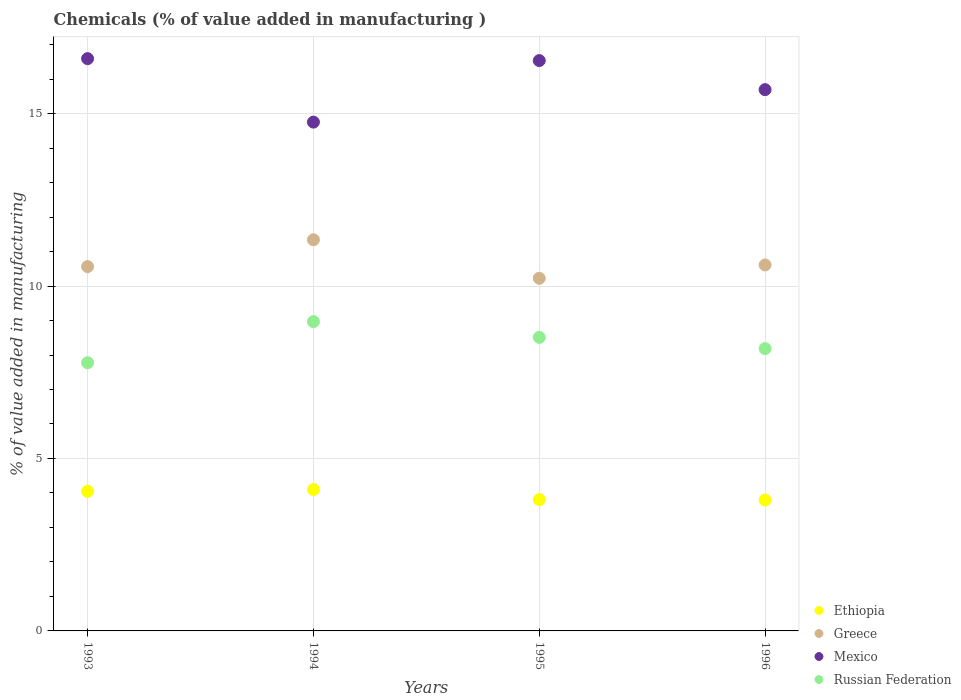Is the number of dotlines equal to the number of legend labels?
Provide a succinct answer. Yes. What is the value added in manufacturing chemicals in Ethiopia in 1994?
Offer a terse response. 4.1. Across all years, what is the maximum value added in manufacturing chemicals in Russian Federation?
Offer a very short reply. 8.97. Across all years, what is the minimum value added in manufacturing chemicals in Greece?
Give a very brief answer. 10.22. In which year was the value added in manufacturing chemicals in Mexico maximum?
Offer a very short reply. 1993. What is the total value added in manufacturing chemicals in Greece in the graph?
Offer a very short reply. 42.74. What is the difference between the value added in manufacturing chemicals in Ethiopia in 1994 and that in 1996?
Offer a terse response. 0.3. What is the difference between the value added in manufacturing chemicals in Mexico in 1995 and the value added in manufacturing chemicals in Greece in 1996?
Keep it short and to the point. 5.93. What is the average value added in manufacturing chemicals in Russian Federation per year?
Your response must be concise. 8.36. In the year 1996, what is the difference between the value added in manufacturing chemicals in Russian Federation and value added in manufacturing chemicals in Greece?
Offer a terse response. -2.43. What is the ratio of the value added in manufacturing chemicals in Ethiopia in 1995 to that in 1996?
Offer a very short reply. 1. Is the value added in manufacturing chemicals in Mexico in 1994 less than that in 1995?
Your response must be concise. Yes. Is the difference between the value added in manufacturing chemicals in Russian Federation in 1994 and 1995 greater than the difference between the value added in manufacturing chemicals in Greece in 1994 and 1995?
Give a very brief answer. No. What is the difference between the highest and the second highest value added in manufacturing chemicals in Russian Federation?
Keep it short and to the point. 0.46. What is the difference between the highest and the lowest value added in manufacturing chemicals in Greece?
Offer a terse response. 1.12. Is it the case that in every year, the sum of the value added in manufacturing chemicals in Ethiopia and value added in manufacturing chemicals in Russian Federation  is greater than the sum of value added in manufacturing chemicals in Greece and value added in manufacturing chemicals in Mexico?
Your answer should be compact. No. Does the value added in manufacturing chemicals in Mexico monotonically increase over the years?
Your answer should be compact. No. How many years are there in the graph?
Offer a terse response. 4. What is the difference between two consecutive major ticks on the Y-axis?
Offer a terse response. 5. Are the values on the major ticks of Y-axis written in scientific E-notation?
Ensure brevity in your answer.  No. Does the graph contain any zero values?
Provide a short and direct response. No. How many legend labels are there?
Offer a terse response. 4. How are the legend labels stacked?
Your response must be concise. Vertical. What is the title of the graph?
Your answer should be very brief. Chemicals (% of value added in manufacturing ). What is the label or title of the X-axis?
Provide a succinct answer. Years. What is the label or title of the Y-axis?
Offer a very short reply. % of value added in manufacturing. What is the % of value added in manufacturing in Ethiopia in 1993?
Ensure brevity in your answer.  4.05. What is the % of value added in manufacturing of Greece in 1993?
Keep it short and to the point. 10.56. What is the % of value added in manufacturing in Mexico in 1993?
Make the answer very short. 16.59. What is the % of value added in manufacturing in Russian Federation in 1993?
Offer a very short reply. 7.78. What is the % of value added in manufacturing in Ethiopia in 1994?
Make the answer very short. 4.1. What is the % of value added in manufacturing of Greece in 1994?
Offer a terse response. 11.34. What is the % of value added in manufacturing in Mexico in 1994?
Provide a succinct answer. 14.75. What is the % of value added in manufacturing in Russian Federation in 1994?
Give a very brief answer. 8.97. What is the % of value added in manufacturing in Ethiopia in 1995?
Your response must be concise. 3.81. What is the % of value added in manufacturing in Greece in 1995?
Ensure brevity in your answer.  10.22. What is the % of value added in manufacturing of Mexico in 1995?
Your answer should be compact. 16.54. What is the % of value added in manufacturing in Russian Federation in 1995?
Your response must be concise. 8.51. What is the % of value added in manufacturing of Ethiopia in 1996?
Keep it short and to the point. 3.8. What is the % of value added in manufacturing in Greece in 1996?
Make the answer very short. 10.61. What is the % of value added in manufacturing in Mexico in 1996?
Keep it short and to the point. 15.69. What is the % of value added in manufacturing in Russian Federation in 1996?
Your response must be concise. 8.19. Across all years, what is the maximum % of value added in manufacturing of Ethiopia?
Your response must be concise. 4.1. Across all years, what is the maximum % of value added in manufacturing of Greece?
Your answer should be compact. 11.34. Across all years, what is the maximum % of value added in manufacturing of Mexico?
Provide a short and direct response. 16.59. Across all years, what is the maximum % of value added in manufacturing in Russian Federation?
Make the answer very short. 8.97. Across all years, what is the minimum % of value added in manufacturing in Ethiopia?
Give a very brief answer. 3.8. Across all years, what is the minimum % of value added in manufacturing of Greece?
Keep it short and to the point. 10.22. Across all years, what is the minimum % of value added in manufacturing of Mexico?
Your response must be concise. 14.75. Across all years, what is the minimum % of value added in manufacturing of Russian Federation?
Offer a terse response. 7.78. What is the total % of value added in manufacturing of Ethiopia in the graph?
Provide a succinct answer. 15.75. What is the total % of value added in manufacturing of Greece in the graph?
Keep it short and to the point. 42.74. What is the total % of value added in manufacturing in Mexico in the graph?
Offer a very short reply. 63.58. What is the total % of value added in manufacturing in Russian Federation in the graph?
Ensure brevity in your answer.  33.44. What is the difference between the % of value added in manufacturing in Ethiopia in 1993 and that in 1994?
Offer a terse response. -0.05. What is the difference between the % of value added in manufacturing in Greece in 1993 and that in 1994?
Your answer should be very brief. -0.78. What is the difference between the % of value added in manufacturing of Mexico in 1993 and that in 1994?
Make the answer very short. 1.84. What is the difference between the % of value added in manufacturing of Russian Federation in 1993 and that in 1994?
Make the answer very short. -1.19. What is the difference between the % of value added in manufacturing of Ethiopia in 1993 and that in 1995?
Make the answer very short. 0.24. What is the difference between the % of value added in manufacturing in Greece in 1993 and that in 1995?
Your answer should be very brief. 0.34. What is the difference between the % of value added in manufacturing in Mexico in 1993 and that in 1995?
Your answer should be compact. 0.06. What is the difference between the % of value added in manufacturing of Russian Federation in 1993 and that in 1995?
Provide a short and direct response. -0.73. What is the difference between the % of value added in manufacturing of Ethiopia in 1993 and that in 1996?
Offer a very short reply. 0.25. What is the difference between the % of value added in manufacturing in Greece in 1993 and that in 1996?
Your answer should be compact. -0.05. What is the difference between the % of value added in manufacturing of Mexico in 1993 and that in 1996?
Your answer should be compact. 0.9. What is the difference between the % of value added in manufacturing of Russian Federation in 1993 and that in 1996?
Provide a succinct answer. -0.41. What is the difference between the % of value added in manufacturing in Ethiopia in 1994 and that in 1995?
Your response must be concise. 0.29. What is the difference between the % of value added in manufacturing in Greece in 1994 and that in 1995?
Provide a short and direct response. 1.12. What is the difference between the % of value added in manufacturing of Mexico in 1994 and that in 1995?
Your answer should be compact. -1.78. What is the difference between the % of value added in manufacturing of Russian Federation in 1994 and that in 1995?
Offer a terse response. 0.46. What is the difference between the % of value added in manufacturing in Ethiopia in 1994 and that in 1996?
Ensure brevity in your answer.  0.3. What is the difference between the % of value added in manufacturing in Greece in 1994 and that in 1996?
Your response must be concise. 0.73. What is the difference between the % of value added in manufacturing in Mexico in 1994 and that in 1996?
Your answer should be very brief. -0.94. What is the difference between the % of value added in manufacturing in Russian Federation in 1994 and that in 1996?
Provide a short and direct response. 0.78. What is the difference between the % of value added in manufacturing of Ethiopia in 1995 and that in 1996?
Provide a succinct answer. 0.01. What is the difference between the % of value added in manufacturing in Greece in 1995 and that in 1996?
Keep it short and to the point. -0.39. What is the difference between the % of value added in manufacturing in Mexico in 1995 and that in 1996?
Give a very brief answer. 0.84. What is the difference between the % of value added in manufacturing of Russian Federation in 1995 and that in 1996?
Your answer should be very brief. 0.32. What is the difference between the % of value added in manufacturing in Ethiopia in 1993 and the % of value added in manufacturing in Greece in 1994?
Provide a succinct answer. -7.29. What is the difference between the % of value added in manufacturing of Ethiopia in 1993 and the % of value added in manufacturing of Mexico in 1994?
Offer a very short reply. -10.7. What is the difference between the % of value added in manufacturing in Ethiopia in 1993 and the % of value added in manufacturing in Russian Federation in 1994?
Your answer should be very brief. -4.92. What is the difference between the % of value added in manufacturing in Greece in 1993 and the % of value added in manufacturing in Mexico in 1994?
Your answer should be compact. -4.19. What is the difference between the % of value added in manufacturing in Greece in 1993 and the % of value added in manufacturing in Russian Federation in 1994?
Your response must be concise. 1.6. What is the difference between the % of value added in manufacturing in Mexico in 1993 and the % of value added in manufacturing in Russian Federation in 1994?
Your answer should be compact. 7.62. What is the difference between the % of value added in manufacturing in Ethiopia in 1993 and the % of value added in manufacturing in Greece in 1995?
Offer a very short reply. -6.18. What is the difference between the % of value added in manufacturing of Ethiopia in 1993 and the % of value added in manufacturing of Mexico in 1995?
Keep it short and to the point. -12.49. What is the difference between the % of value added in manufacturing of Ethiopia in 1993 and the % of value added in manufacturing of Russian Federation in 1995?
Your response must be concise. -4.46. What is the difference between the % of value added in manufacturing of Greece in 1993 and the % of value added in manufacturing of Mexico in 1995?
Your response must be concise. -5.97. What is the difference between the % of value added in manufacturing of Greece in 1993 and the % of value added in manufacturing of Russian Federation in 1995?
Your answer should be very brief. 2.05. What is the difference between the % of value added in manufacturing of Mexico in 1993 and the % of value added in manufacturing of Russian Federation in 1995?
Provide a short and direct response. 8.08. What is the difference between the % of value added in manufacturing in Ethiopia in 1993 and the % of value added in manufacturing in Greece in 1996?
Offer a very short reply. -6.56. What is the difference between the % of value added in manufacturing in Ethiopia in 1993 and the % of value added in manufacturing in Mexico in 1996?
Provide a short and direct response. -11.64. What is the difference between the % of value added in manufacturing in Ethiopia in 1993 and the % of value added in manufacturing in Russian Federation in 1996?
Your answer should be compact. -4.14. What is the difference between the % of value added in manufacturing in Greece in 1993 and the % of value added in manufacturing in Mexico in 1996?
Give a very brief answer. -5.13. What is the difference between the % of value added in manufacturing in Greece in 1993 and the % of value added in manufacturing in Russian Federation in 1996?
Offer a terse response. 2.38. What is the difference between the % of value added in manufacturing in Mexico in 1993 and the % of value added in manufacturing in Russian Federation in 1996?
Offer a terse response. 8.41. What is the difference between the % of value added in manufacturing of Ethiopia in 1994 and the % of value added in manufacturing of Greece in 1995?
Offer a terse response. -6.13. What is the difference between the % of value added in manufacturing of Ethiopia in 1994 and the % of value added in manufacturing of Mexico in 1995?
Provide a short and direct response. -12.44. What is the difference between the % of value added in manufacturing in Ethiopia in 1994 and the % of value added in manufacturing in Russian Federation in 1995?
Make the answer very short. -4.41. What is the difference between the % of value added in manufacturing of Greece in 1994 and the % of value added in manufacturing of Mexico in 1995?
Provide a short and direct response. -5.2. What is the difference between the % of value added in manufacturing of Greece in 1994 and the % of value added in manufacturing of Russian Federation in 1995?
Offer a terse response. 2.83. What is the difference between the % of value added in manufacturing in Mexico in 1994 and the % of value added in manufacturing in Russian Federation in 1995?
Your answer should be very brief. 6.24. What is the difference between the % of value added in manufacturing of Ethiopia in 1994 and the % of value added in manufacturing of Greece in 1996?
Provide a short and direct response. -6.51. What is the difference between the % of value added in manufacturing in Ethiopia in 1994 and the % of value added in manufacturing in Mexico in 1996?
Make the answer very short. -11.6. What is the difference between the % of value added in manufacturing of Ethiopia in 1994 and the % of value added in manufacturing of Russian Federation in 1996?
Make the answer very short. -4.09. What is the difference between the % of value added in manufacturing in Greece in 1994 and the % of value added in manufacturing in Mexico in 1996?
Give a very brief answer. -4.35. What is the difference between the % of value added in manufacturing in Greece in 1994 and the % of value added in manufacturing in Russian Federation in 1996?
Your response must be concise. 3.15. What is the difference between the % of value added in manufacturing in Mexico in 1994 and the % of value added in manufacturing in Russian Federation in 1996?
Your answer should be compact. 6.57. What is the difference between the % of value added in manufacturing in Ethiopia in 1995 and the % of value added in manufacturing in Greece in 1996?
Your response must be concise. -6.8. What is the difference between the % of value added in manufacturing in Ethiopia in 1995 and the % of value added in manufacturing in Mexico in 1996?
Provide a short and direct response. -11.89. What is the difference between the % of value added in manufacturing in Ethiopia in 1995 and the % of value added in manufacturing in Russian Federation in 1996?
Ensure brevity in your answer.  -4.38. What is the difference between the % of value added in manufacturing of Greece in 1995 and the % of value added in manufacturing of Mexico in 1996?
Ensure brevity in your answer.  -5.47. What is the difference between the % of value added in manufacturing of Greece in 1995 and the % of value added in manufacturing of Russian Federation in 1996?
Give a very brief answer. 2.04. What is the difference between the % of value added in manufacturing in Mexico in 1995 and the % of value added in manufacturing in Russian Federation in 1996?
Offer a very short reply. 8.35. What is the average % of value added in manufacturing of Ethiopia per year?
Provide a short and direct response. 3.94. What is the average % of value added in manufacturing in Greece per year?
Make the answer very short. 10.69. What is the average % of value added in manufacturing of Mexico per year?
Ensure brevity in your answer.  15.89. What is the average % of value added in manufacturing of Russian Federation per year?
Your answer should be compact. 8.36. In the year 1993, what is the difference between the % of value added in manufacturing in Ethiopia and % of value added in manufacturing in Greece?
Provide a short and direct response. -6.51. In the year 1993, what is the difference between the % of value added in manufacturing in Ethiopia and % of value added in manufacturing in Mexico?
Make the answer very short. -12.54. In the year 1993, what is the difference between the % of value added in manufacturing of Ethiopia and % of value added in manufacturing of Russian Federation?
Offer a very short reply. -3.73. In the year 1993, what is the difference between the % of value added in manufacturing of Greece and % of value added in manufacturing of Mexico?
Give a very brief answer. -6.03. In the year 1993, what is the difference between the % of value added in manufacturing of Greece and % of value added in manufacturing of Russian Federation?
Your response must be concise. 2.79. In the year 1993, what is the difference between the % of value added in manufacturing in Mexico and % of value added in manufacturing in Russian Federation?
Your answer should be compact. 8.82. In the year 1994, what is the difference between the % of value added in manufacturing of Ethiopia and % of value added in manufacturing of Greece?
Provide a short and direct response. -7.24. In the year 1994, what is the difference between the % of value added in manufacturing of Ethiopia and % of value added in manufacturing of Mexico?
Make the answer very short. -10.65. In the year 1994, what is the difference between the % of value added in manufacturing in Ethiopia and % of value added in manufacturing in Russian Federation?
Ensure brevity in your answer.  -4.87. In the year 1994, what is the difference between the % of value added in manufacturing in Greece and % of value added in manufacturing in Mexico?
Your answer should be very brief. -3.41. In the year 1994, what is the difference between the % of value added in manufacturing of Greece and % of value added in manufacturing of Russian Federation?
Make the answer very short. 2.37. In the year 1994, what is the difference between the % of value added in manufacturing of Mexico and % of value added in manufacturing of Russian Federation?
Your answer should be very brief. 5.78. In the year 1995, what is the difference between the % of value added in manufacturing of Ethiopia and % of value added in manufacturing of Greece?
Provide a succinct answer. -6.42. In the year 1995, what is the difference between the % of value added in manufacturing of Ethiopia and % of value added in manufacturing of Mexico?
Offer a terse response. -12.73. In the year 1995, what is the difference between the % of value added in manufacturing in Ethiopia and % of value added in manufacturing in Russian Federation?
Provide a succinct answer. -4.7. In the year 1995, what is the difference between the % of value added in manufacturing of Greece and % of value added in manufacturing of Mexico?
Make the answer very short. -6.31. In the year 1995, what is the difference between the % of value added in manufacturing of Greece and % of value added in manufacturing of Russian Federation?
Your response must be concise. 1.71. In the year 1995, what is the difference between the % of value added in manufacturing of Mexico and % of value added in manufacturing of Russian Federation?
Keep it short and to the point. 8.03. In the year 1996, what is the difference between the % of value added in manufacturing in Ethiopia and % of value added in manufacturing in Greece?
Offer a very short reply. -6.82. In the year 1996, what is the difference between the % of value added in manufacturing in Ethiopia and % of value added in manufacturing in Mexico?
Your answer should be compact. -11.9. In the year 1996, what is the difference between the % of value added in manufacturing in Ethiopia and % of value added in manufacturing in Russian Federation?
Provide a succinct answer. -4.39. In the year 1996, what is the difference between the % of value added in manufacturing in Greece and % of value added in manufacturing in Mexico?
Your answer should be compact. -5.08. In the year 1996, what is the difference between the % of value added in manufacturing of Greece and % of value added in manufacturing of Russian Federation?
Your answer should be compact. 2.43. In the year 1996, what is the difference between the % of value added in manufacturing of Mexico and % of value added in manufacturing of Russian Federation?
Your response must be concise. 7.51. What is the ratio of the % of value added in manufacturing in Ethiopia in 1993 to that in 1994?
Offer a terse response. 0.99. What is the ratio of the % of value added in manufacturing in Greece in 1993 to that in 1994?
Make the answer very short. 0.93. What is the ratio of the % of value added in manufacturing in Mexico in 1993 to that in 1994?
Offer a very short reply. 1.12. What is the ratio of the % of value added in manufacturing of Russian Federation in 1993 to that in 1994?
Ensure brevity in your answer.  0.87. What is the ratio of the % of value added in manufacturing of Ethiopia in 1993 to that in 1995?
Offer a very short reply. 1.06. What is the ratio of the % of value added in manufacturing of Greece in 1993 to that in 1995?
Offer a terse response. 1.03. What is the ratio of the % of value added in manufacturing in Russian Federation in 1993 to that in 1995?
Make the answer very short. 0.91. What is the ratio of the % of value added in manufacturing in Ethiopia in 1993 to that in 1996?
Your response must be concise. 1.07. What is the ratio of the % of value added in manufacturing in Mexico in 1993 to that in 1996?
Offer a very short reply. 1.06. What is the ratio of the % of value added in manufacturing of Russian Federation in 1993 to that in 1996?
Provide a succinct answer. 0.95. What is the ratio of the % of value added in manufacturing of Ethiopia in 1994 to that in 1995?
Make the answer very short. 1.08. What is the ratio of the % of value added in manufacturing in Greece in 1994 to that in 1995?
Keep it short and to the point. 1.11. What is the ratio of the % of value added in manufacturing in Mexico in 1994 to that in 1995?
Ensure brevity in your answer.  0.89. What is the ratio of the % of value added in manufacturing in Russian Federation in 1994 to that in 1995?
Your answer should be very brief. 1.05. What is the ratio of the % of value added in manufacturing in Ethiopia in 1994 to that in 1996?
Ensure brevity in your answer.  1.08. What is the ratio of the % of value added in manufacturing of Greece in 1994 to that in 1996?
Make the answer very short. 1.07. What is the ratio of the % of value added in manufacturing of Mexico in 1994 to that in 1996?
Provide a short and direct response. 0.94. What is the ratio of the % of value added in manufacturing of Russian Federation in 1994 to that in 1996?
Your response must be concise. 1.1. What is the ratio of the % of value added in manufacturing of Greece in 1995 to that in 1996?
Give a very brief answer. 0.96. What is the ratio of the % of value added in manufacturing of Mexico in 1995 to that in 1996?
Give a very brief answer. 1.05. What is the ratio of the % of value added in manufacturing of Russian Federation in 1995 to that in 1996?
Make the answer very short. 1.04. What is the difference between the highest and the second highest % of value added in manufacturing in Ethiopia?
Your answer should be compact. 0.05. What is the difference between the highest and the second highest % of value added in manufacturing of Greece?
Your answer should be very brief. 0.73. What is the difference between the highest and the second highest % of value added in manufacturing of Mexico?
Ensure brevity in your answer.  0.06. What is the difference between the highest and the second highest % of value added in manufacturing of Russian Federation?
Offer a very short reply. 0.46. What is the difference between the highest and the lowest % of value added in manufacturing in Ethiopia?
Provide a succinct answer. 0.3. What is the difference between the highest and the lowest % of value added in manufacturing in Greece?
Keep it short and to the point. 1.12. What is the difference between the highest and the lowest % of value added in manufacturing of Mexico?
Make the answer very short. 1.84. What is the difference between the highest and the lowest % of value added in manufacturing in Russian Federation?
Keep it short and to the point. 1.19. 